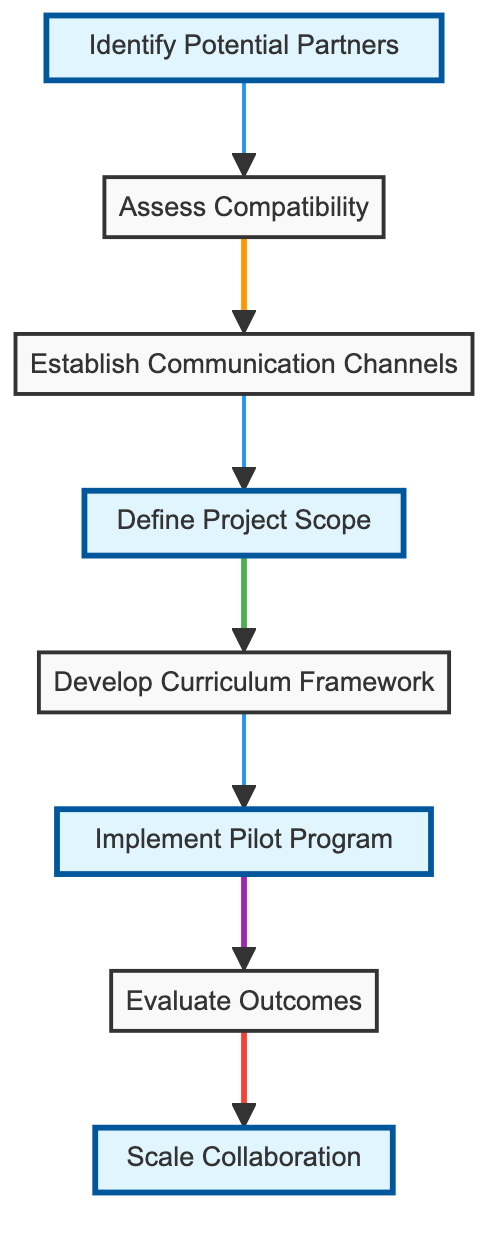What is the first step in the collaboration project? The first step is identified by the starting node in the flowchart, labeled "Identify Potential Partners." This node is positioned at the top and initiates the process.
Answer: Identify Potential Partners How many steps are involved in the international collaboration project? By counting the nodes in the flowchart, there are eight distinct steps outlined for the collaboration project.
Answer: Eight What step follows 'Implement Pilot Program'? The flowchart shows an arrow from 'Implement Pilot Program' to 'Evaluate Outcomes,' indicating that this is the next step in the process.
Answer: Evaluate Outcomes Which two steps are highlighted in the diagram? The highlighted steps can be identified by their different visual styling; they are "Define Project Scope" and "Scale Collaboration."
Answer: Define Project Scope, Scale Collaboration What is the relationship between 'Assess Compatibility' and 'Establish Communication Channels'? The relationship is established through the directed arrow connecting these two nodes in the flowchart, indicating that 'Assess Compatibility' leads to 'Establish Communication Channels.'
Answer: 'Assess Compatibility' leads to 'Establish Communication Channels' What is the last step in the project flow? The last step can be determined by examining where the final arrow in the flowchart points; it directs towards 'Scale Collaboration,' marking it as the final phase of the project.
Answer: Scale Collaboration What do the highlighted steps indicate? The highlighted steps emphasize important phases within the workflow, suggesting they may be critical for the project's success and drawing attention to them in the diagram.
Answer: Critical phases What are the italicized steps in the flowchart? Examining the style of the nodes, the italicized steps in the flowchart are "Assess Compatibility" and "Develop Curriculum Framework."
Answer: Assess Compatibility, Develop Curriculum Framework In which step is the curriculum developed? The flowchart indicates that the curriculum is developed in the step labeled "Develop Curriculum Framework," making it clear where this activity occurs.
Answer: Develop Curriculum Framework 